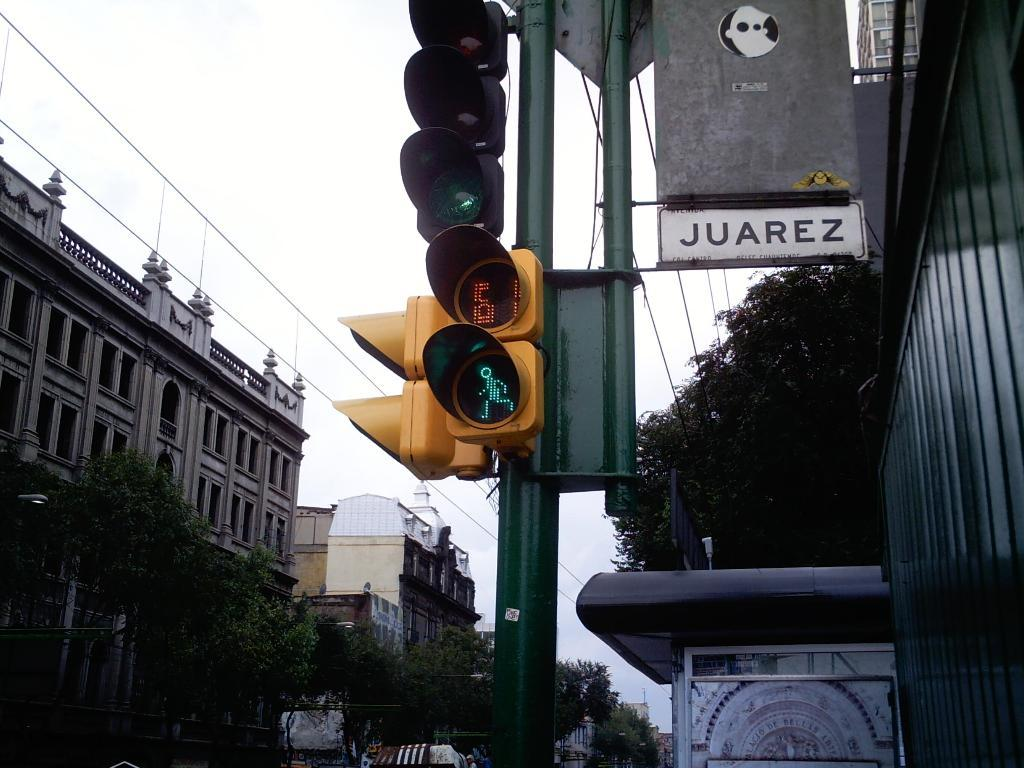What is located in the middle of the image? There are traffic signal lights in the middle of the image. What type of vegetation can be seen on either side of the image? There are trees on either side of the image. What type of structures are visible in the image? There are buildings visible in the image. What is visible at the top of the image? The sky is visible at the top of the image. What type of hammer is being used to process the throat in the image? There is no hammer or throat present in the image; it features traffic signal lights, trees, buildings, and the sky. 